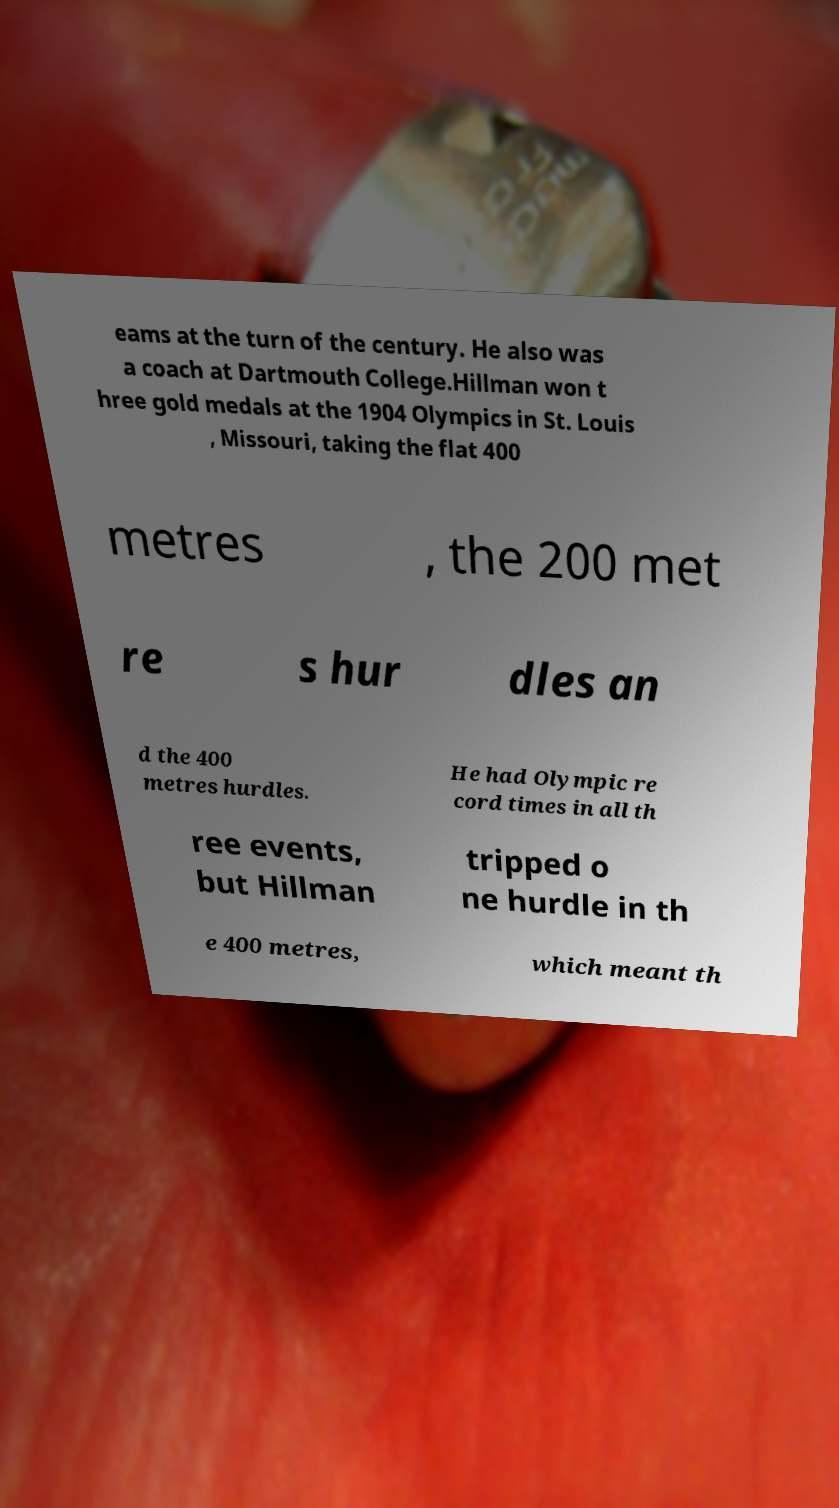Can you read and provide the text displayed in the image?This photo seems to have some interesting text. Can you extract and type it out for me? eams at the turn of the century. He also was a coach at Dartmouth College.Hillman won t hree gold medals at the 1904 Olympics in St. Louis , Missouri, taking the flat 400 metres , the 200 met re s hur dles an d the 400 metres hurdles. He had Olympic re cord times in all th ree events, but Hillman tripped o ne hurdle in th e 400 metres, which meant th 